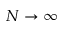Convert formula to latex. <formula><loc_0><loc_0><loc_500><loc_500>N \to \infty</formula> 